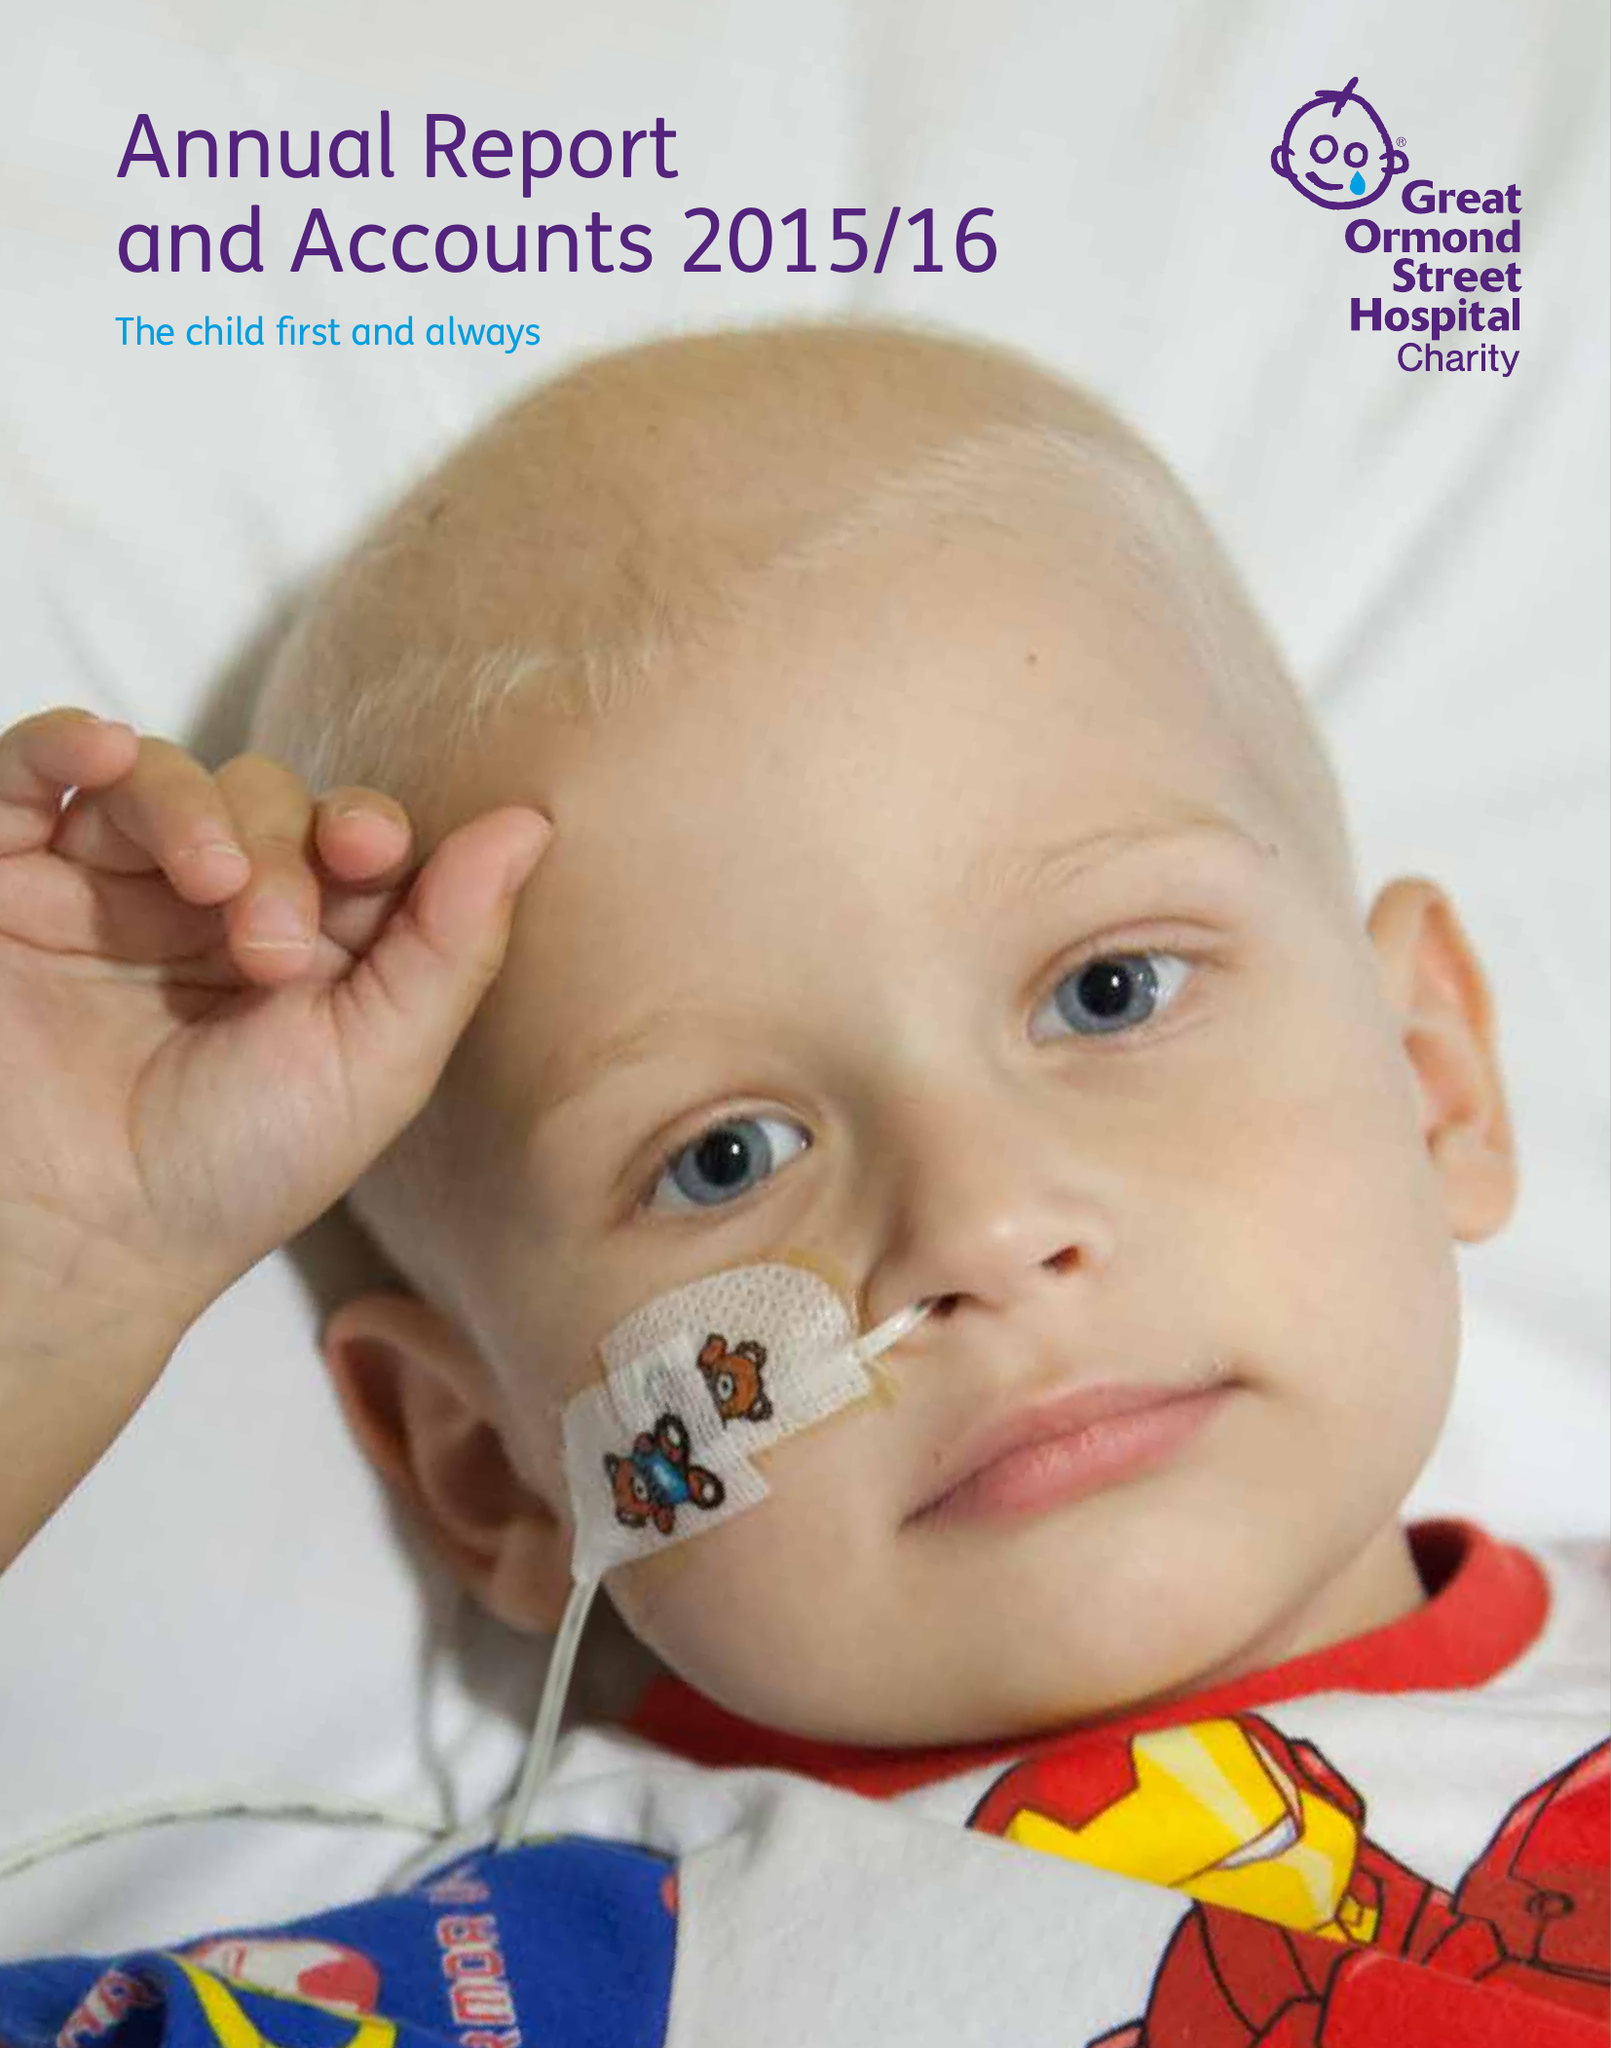What is the value for the charity_name?
Answer the question using a single word or phrase. Great Ormond Street Hospital Children's Charity 